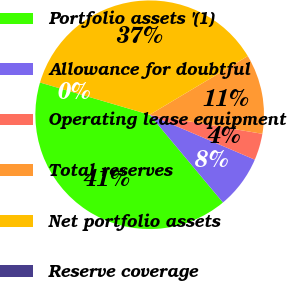Convert chart. <chart><loc_0><loc_0><loc_500><loc_500><pie_chart><fcel>Portfolio assets '(1)<fcel>Allowance for doubtful<fcel>Operating lease equipment<fcel>Total reserves<fcel>Net portfolio assets<fcel>Reserve coverage<nl><fcel>40.61%<fcel>7.5%<fcel>3.76%<fcel>11.25%<fcel>36.86%<fcel>0.01%<nl></chart> 